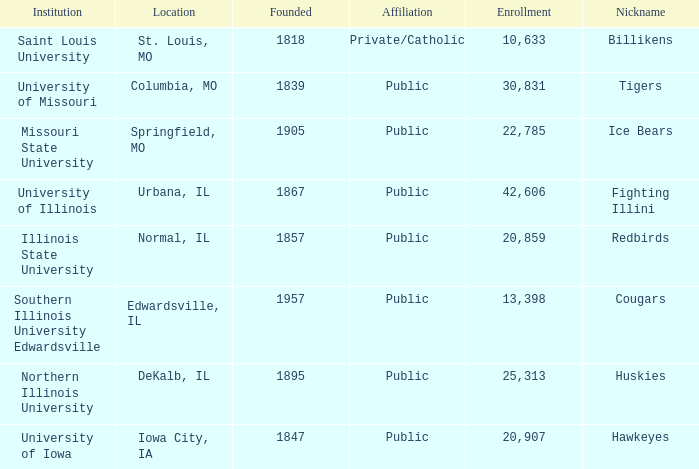What is Southern Illinois University Edwardsville's affiliation? Public. 